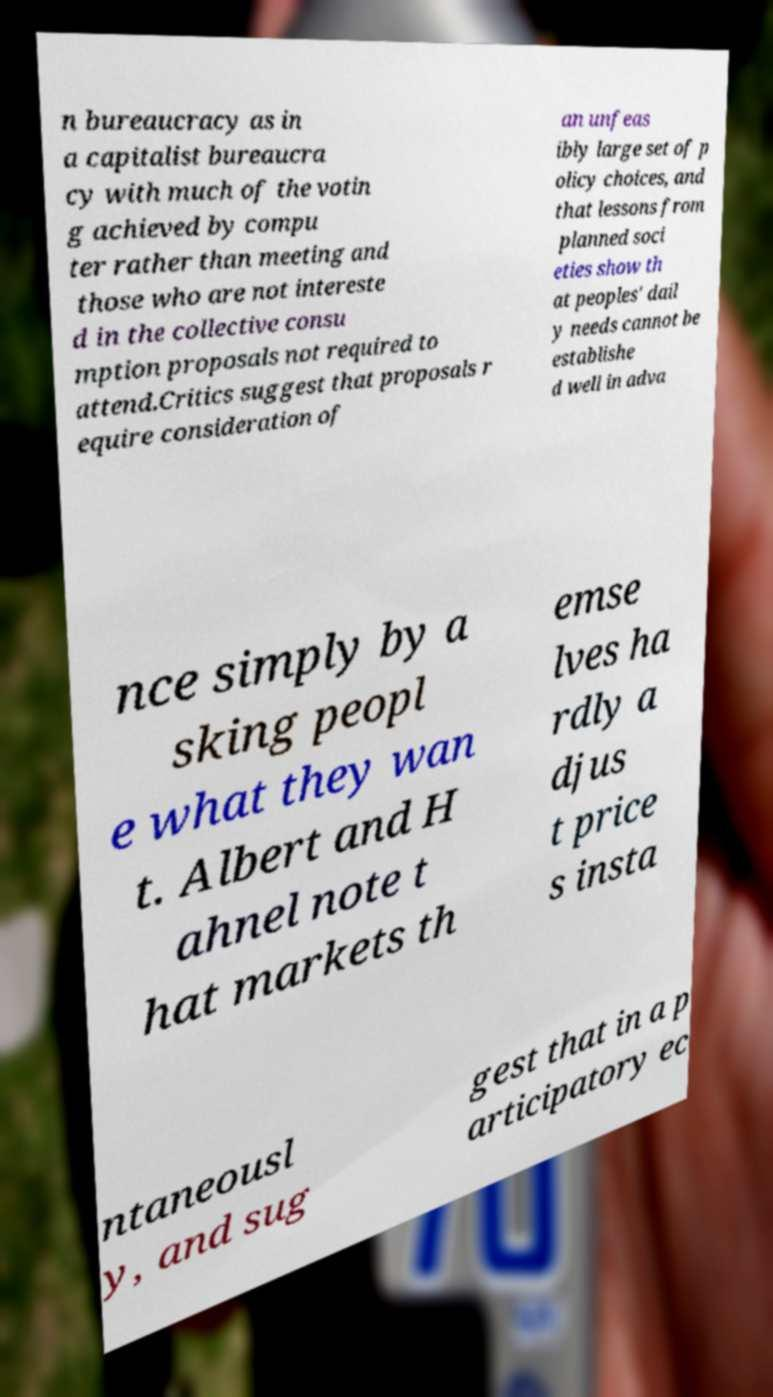Please identify and transcribe the text found in this image. n bureaucracy as in a capitalist bureaucra cy with much of the votin g achieved by compu ter rather than meeting and those who are not intereste d in the collective consu mption proposals not required to attend.Critics suggest that proposals r equire consideration of an unfeas ibly large set of p olicy choices, and that lessons from planned soci eties show th at peoples' dail y needs cannot be establishe d well in adva nce simply by a sking peopl e what they wan t. Albert and H ahnel note t hat markets th emse lves ha rdly a djus t price s insta ntaneousl y, and sug gest that in a p articipatory ec 